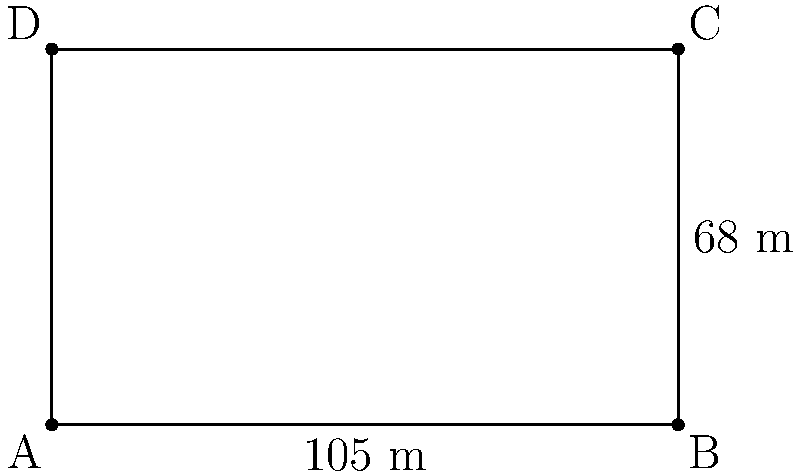As a football enthusiast, you're curious about the dimensions of a standard football field. Given that a rectangular field has a length of 105 meters and a width of 68 meters, calculate its total area in square meters. How might this information be relevant in discussions about stadium capacity or game strategy in your political science studies? To calculate the area of the rectangular football field, we need to multiply its length by its width. Let's break it down step-by-step:

1. Identify the given dimensions:
   - Length = 105 meters
   - Width = 68 meters

2. Apply the formula for the area of a rectangle:
   $$ \text{Area} = \text{Length} \times \text{Width} $$

3. Substitute the values into the formula:
   $$ \text{Area} = 105 \text{ m} \times 68 \text{ m} $$

4. Perform the multiplication:
   $$ \text{Area} = 7,140 \text{ m}^2 $$

The relevance to political science studies could include:
- Analyzing the impact of stadium size on local politics and urban planning
- Studying the relationship between field size and game strategies in international competitions
- Examining how field dimensions affect the economic aspects of hosting major football events
Answer: $7,140 \text{ m}^2$ 